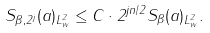<formula> <loc_0><loc_0><loc_500><loc_500>\| S _ { \beta , 2 ^ { j } } ( a ) \| _ { L ^ { 2 } _ { w } } \leq C \cdot 2 ^ { j n / 2 } \| S _ { \beta } ( a ) \| _ { L ^ { 2 } _ { w } } .</formula> 